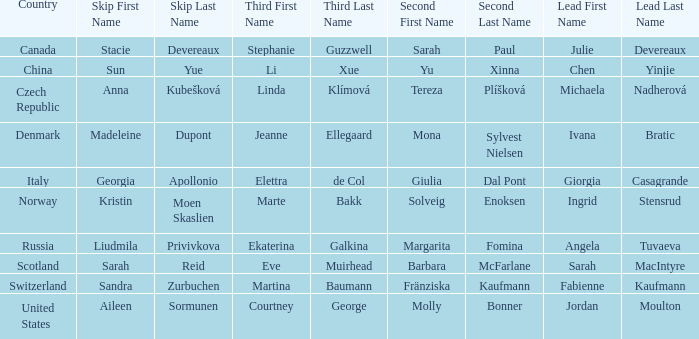What skip has denmark as the country? Madeleine Dupont. 